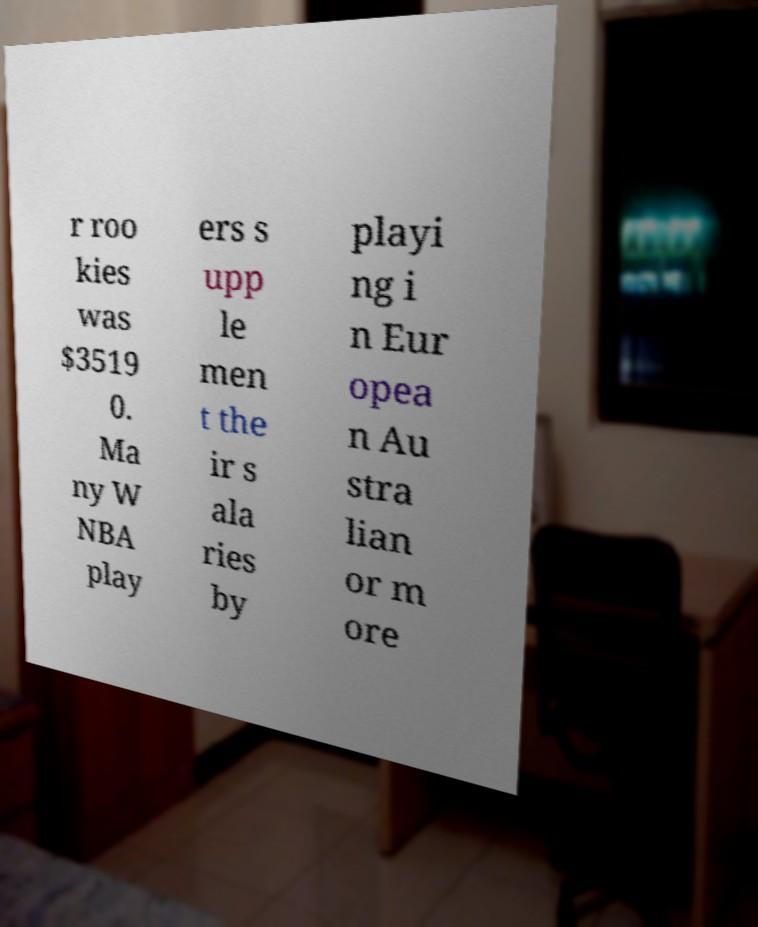There's text embedded in this image that I need extracted. Can you transcribe it verbatim? r roo kies was $3519 0. Ma ny W NBA play ers s upp le men t the ir s ala ries by playi ng i n Eur opea n Au stra lian or m ore 